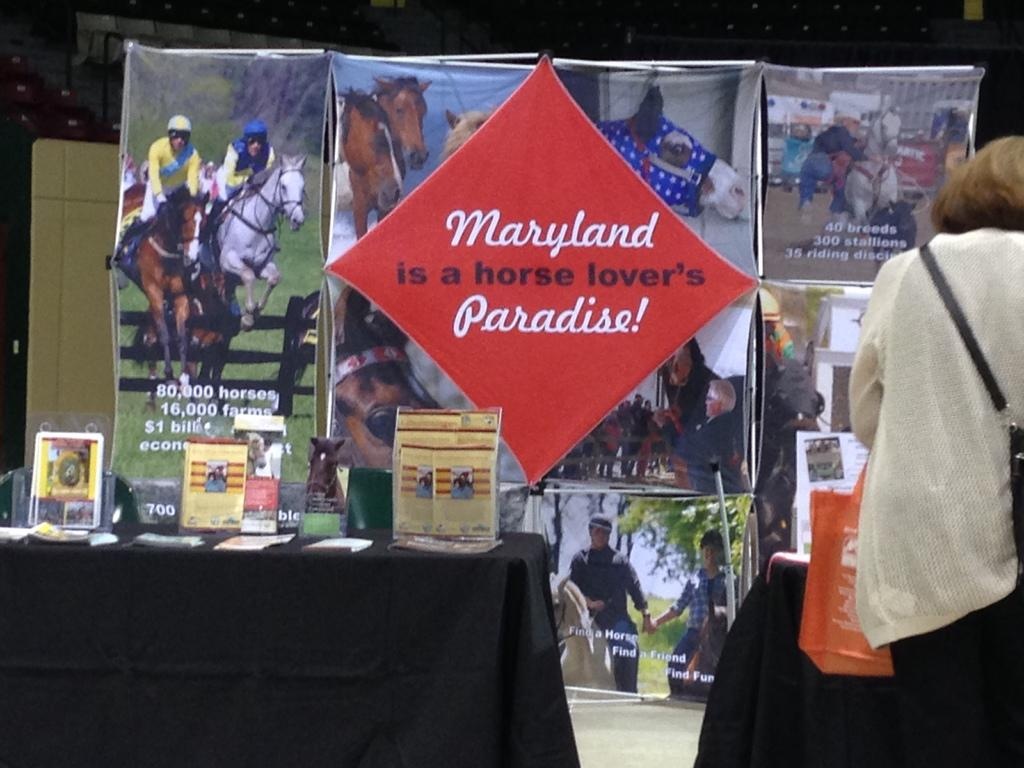Provide a one-sentence caption for the provided image. a display table with phampletes about Maryland and horses. 